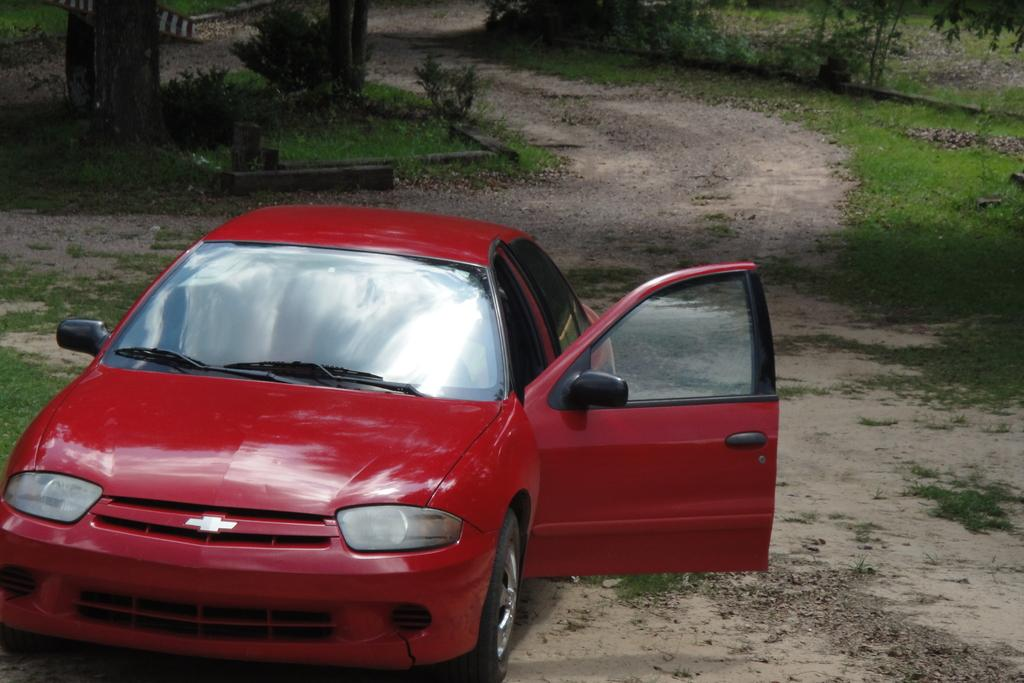What is located on the ground in the image? There is a car on the ground in the image. What type of natural environment can be seen in the background of the image? There is grass, plants, and trees visible in the background of the image. What type of brake is being used by the car in the image? There is no indication of the car's braking system in the image, so it cannot be determined. How does the car show care for the environment in the image? The image does not provide any information about the car's impact on the environment or its level of care for it. 